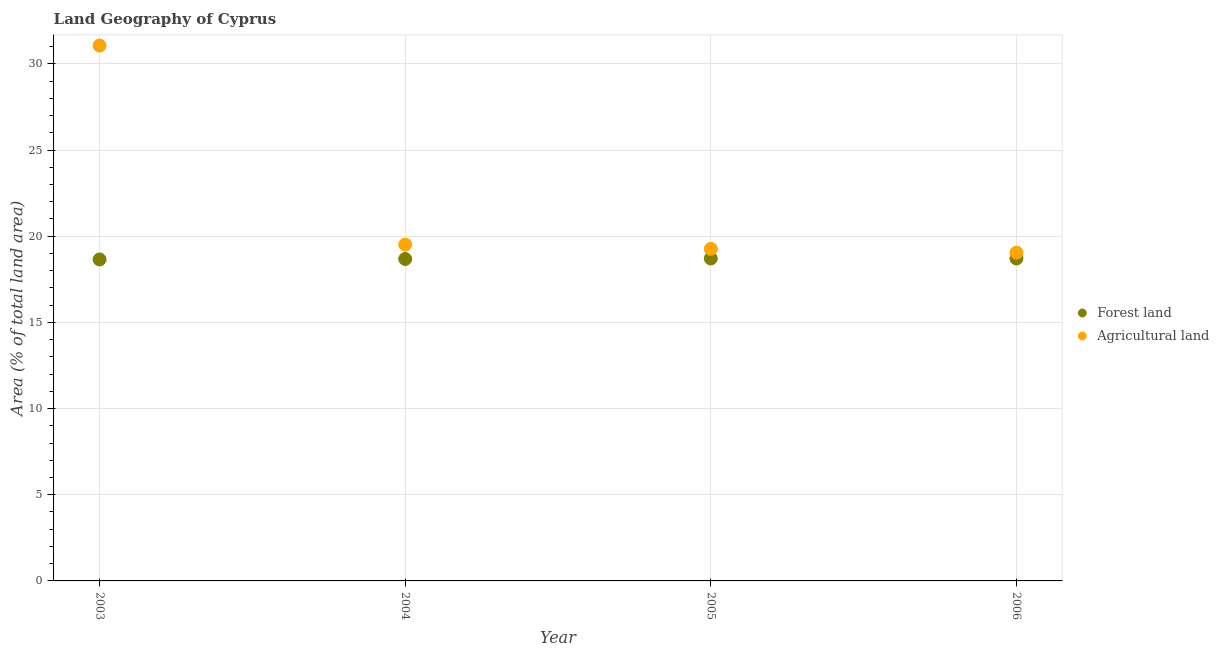What is the percentage of land area under forests in 2006?
Your answer should be compact. 18.71. Across all years, what is the maximum percentage of land area under forests?
Your answer should be very brief. 18.71. Across all years, what is the minimum percentage of land area under agriculture?
Ensure brevity in your answer.  19.05. In which year was the percentage of land area under agriculture minimum?
Offer a terse response. 2006. What is the total percentage of land area under agriculture in the graph?
Offer a very short reply. 88.89. What is the difference between the percentage of land area under forests in 2003 and that in 2006?
Keep it short and to the point. -0.05. What is the difference between the percentage of land area under forests in 2003 and the percentage of land area under agriculture in 2006?
Your answer should be very brief. -0.4. What is the average percentage of land area under agriculture per year?
Your answer should be compact. 22.22. In the year 2006, what is the difference between the percentage of land area under agriculture and percentage of land area under forests?
Provide a short and direct response. 0.34. What is the ratio of the percentage of land area under agriculture in 2004 to that in 2006?
Provide a short and direct response. 1.02. What is the difference between the highest and the second highest percentage of land area under forests?
Keep it short and to the point. 0. What is the difference between the highest and the lowest percentage of land area under forests?
Provide a short and direct response. 0.05. In how many years, is the percentage of land area under forests greater than the average percentage of land area under forests taken over all years?
Keep it short and to the point. 2. Is the sum of the percentage of land area under agriculture in 2003 and 2006 greater than the maximum percentage of land area under forests across all years?
Your response must be concise. Yes. Does the percentage of land area under forests monotonically increase over the years?
Your response must be concise. No. Is the percentage of land area under forests strictly greater than the percentage of land area under agriculture over the years?
Offer a terse response. No. Is the percentage of land area under forests strictly less than the percentage of land area under agriculture over the years?
Make the answer very short. Yes. How many years are there in the graph?
Your response must be concise. 4. Are the values on the major ticks of Y-axis written in scientific E-notation?
Provide a short and direct response. No. Where does the legend appear in the graph?
Make the answer very short. Center right. How many legend labels are there?
Your answer should be very brief. 2. What is the title of the graph?
Make the answer very short. Land Geography of Cyprus. What is the label or title of the X-axis?
Give a very brief answer. Year. What is the label or title of the Y-axis?
Ensure brevity in your answer.  Area (% of total land area). What is the Area (% of total land area) of Forest land in 2003?
Offer a very short reply. 18.65. What is the Area (% of total land area) of Agricultural land in 2003?
Provide a succinct answer. 31.06. What is the Area (% of total land area) in Forest land in 2004?
Provide a succinct answer. 18.68. What is the Area (% of total land area) of Agricultural land in 2004?
Provide a succinct answer. 19.51. What is the Area (% of total land area) in Forest land in 2005?
Make the answer very short. 18.71. What is the Area (% of total land area) of Agricultural land in 2005?
Offer a very short reply. 19.26. What is the Area (% of total land area) in Forest land in 2006?
Provide a succinct answer. 18.71. What is the Area (% of total land area) of Agricultural land in 2006?
Make the answer very short. 19.05. Across all years, what is the maximum Area (% of total land area) of Forest land?
Give a very brief answer. 18.71. Across all years, what is the maximum Area (% of total land area) in Agricultural land?
Offer a very short reply. 31.06. Across all years, what is the minimum Area (% of total land area) in Forest land?
Keep it short and to the point. 18.65. Across all years, what is the minimum Area (% of total land area) in Agricultural land?
Keep it short and to the point. 19.05. What is the total Area (% of total land area) of Forest land in the graph?
Keep it short and to the point. 74.75. What is the total Area (% of total land area) of Agricultural land in the graph?
Your response must be concise. 88.89. What is the difference between the Area (% of total land area) of Forest land in 2003 and that in 2004?
Offer a terse response. -0.03. What is the difference between the Area (% of total land area) of Agricultural land in 2003 and that in 2004?
Offer a terse response. 11.55. What is the difference between the Area (% of total land area) in Forest land in 2003 and that in 2005?
Your answer should be compact. -0.05. What is the difference between the Area (% of total land area) in Agricultural land in 2003 and that in 2005?
Offer a very short reply. 11.8. What is the difference between the Area (% of total land area) of Forest land in 2003 and that in 2006?
Your answer should be compact. -0.05. What is the difference between the Area (% of total land area) in Agricultural land in 2003 and that in 2006?
Your response must be concise. 12.01. What is the difference between the Area (% of total land area) in Forest land in 2004 and that in 2005?
Offer a terse response. -0.03. What is the difference between the Area (% of total land area) in Agricultural land in 2004 and that in 2005?
Keep it short and to the point. 0.25. What is the difference between the Area (% of total land area) in Forest land in 2004 and that in 2006?
Offer a very short reply. -0.03. What is the difference between the Area (% of total land area) in Agricultural land in 2004 and that in 2006?
Provide a succinct answer. 0.47. What is the difference between the Area (% of total land area) of Agricultural land in 2005 and that in 2006?
Offer a terse response. 0.22. What is the difference between the Area (% of total land area) in Forest land in 2003 and the Area (% of total land area) in Agricultural land in 2004?
Provide a succinct answer. -0.86. What is the difference between the Area (% of total land area) in Forest land in 2003 and the Area (% of total land area) in Agricultural land in 2005?
Provide a short and direct response. -0.61. What is the difference between the Area (% of total land area) in Forest land in 2003 and the Area (% of total land area) in Agricultural land in 2006?
Your response must be concise. -0.4. What is the difference between the Area (% of total land area) in Forest land in 2004 and the Area (% of total land area) in Agricultural land in 2005?
Your answer should be compact. -0.58. What is the difference between the Area (% of total land area) in Forest land in 2004 and the Area (% of total land area) in Agricultural land in 2006?
Offer a terse response. -0.37. What is the difference between the Area (% of total land area) in Forest land in 2005 and the Area (% of total land area) in Agricultural land in 2006?
Your response must be concise. -0.34. What is the average Area (% of total land area) of Forest land per year?
Make the answer very short. 18.69. What is the average Area (% of total land area) in Agricultural land per year?
Your answer should be very brief. 22.22. In the year 2003, what is the difference between the Area (% of total land area) of Forest land and Area (% of total land area) of Agricultural land?
Provide a succinct answer. -12.41. In the year 2005, what is the difference between the Area (% of total land area) of Forest land and Area (% of total land area) of Agricultural land?
Your answer should be compact. -0.56. In the year 2006, what is the difference between the Area (% of total land area) in Forest land and Area (% of total land area) in Agricultural land?
Ensure brevity in your answer.  -0.34. What is the ratio of the Area (% of total land area) in Agricultural land in 2003 to that in 2004?
Your answer should be compact. 1.59. What is the ratio of the Area (% of total land area) of Agricultural land in 2003 to that in 2005?
Your answer should be compact. 1.61. What is the ratio of the Area (% of total land area) in Forest land in 2003 to that in 2006?
Provide a succinct answer. 1. What is the ratio of the Area (% of total land area) of Agricultural land in 2003 to that in 2006?
Your answer should be compact. 1.63. What is the ratio of the Area (% of total land area) in Agricultural land in 2004 to that in 2005?
Offer a very short reply. 1.01. What is the ratio of the Area (% of total land area) in Forest land in 2004 to that in 2006?
Offer a very short reply. 1. What is the ratio of the Area (% of total land area) of Agricultural land in 2004 to that in 2006?
Make the answer very short. 1.02. What is the ratio of the Area (% of total land area) of Forest land in 2005 to that in 2006?
Provide a short and direct response. 1. What is the ratio of the Area (% of total land area) in Agricultural land in 2005 to that in 2006?
Offer a terse response. 1.01. What is the difference between the highest and the second highest Area (% of total land area) of Forest land?
Give a very brief answer. 0. What is the difference between the highest and the second highest Area (% of total land area) in Agricultural land?
Provide a succinct answer. 11.55. What is the difference between the highest and the lowest Area (% of total land area) of Forest land?
Your answer should be very brief. 0.05. What is the difference between the highest and the lowest Area (% of total land area) of Agricultural land?
Keep it short and to the point. 12.01. 